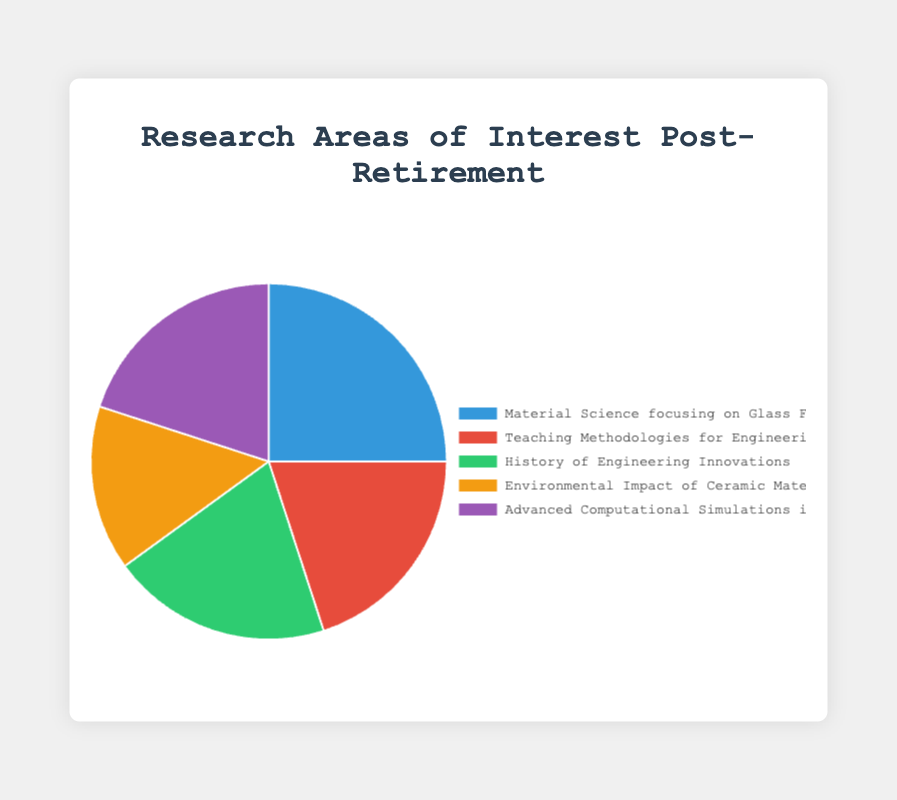What is the most prioritized research area post-retirement according to the pie chart? The highest percentage in the pie chart corresponds to the research area with the greatest priority. Here, "Material Science focusing on Glass Fracture Mechanics" has the highest percentage at 25%.
Answer: "Material Science focusing on Glass Fracture Mechanics" Which research areas have exactly the same percentage? By observing the pie chart, the areas with the same percentage are "Teaching Methodologies for Engineering Education", "History of Engineering Innovations", and "Advanced Computational Simulations in Material Engineering". Each of these areas has a 20% slice in the chart.
Answer: "Teaching Methodologies for Engineering Education", "History of Engineering Innovations", and "Advanced Computational Simulations in Material Engineering" What is the cumulative percentage of research areas related to engineering education and innovation? Adding the percentages of "Teaching Methodologies for Engineering Education" (20%) and "History of Engineering Innovations" (20%), the cumulative percentage is 20% + 20% = 40%.
Answer: 40% Does "Environmental Impact of Ceramic Materials" hold a larger or smaller percentage than "History of Engineering Innovations"? By comparing the percentages, "Environmental Impact of Ceramic Materials" has 15% while "History of Engineering Innovations" has 20%. Therefore, "Environmental Impact of Ceramic Materials" holds a smaller percentage.
Answer: Smaller What is the sum percentage of all the research areas that are directly related to material engineering? Adding the percentages of "Material Science focusing on Glass Fracture Mechanics" (25%), "Environmental Impact of Ceramic Materials" (15%), and "Advanced Computational Simulations in Material Engineering" (20%), the total is 25% + 15% + 20% = 60%.
Answer: 60% What color represents the area "Teaching Methodologies for Engineering Education" in the pie chart? The pie chart will show different colors for each slice. For "Teaching Methodologies for Engineering Education," the specified color is red.
Answer: Red Which research area holds 20% and is represented by the green slice in the chart? By checking both the percentage and corresponding color, "History of Engineering Innovations" has a 20% representation and is shown in green.
Answer: "History of Engineering Innovations" How does the percentage of "Advanced Computational Simulations in Material Engineering" compare to the percentage of "Material Science focusing on Glass Fracture Mechanics"? "Advanced Computational Simulations in Material Engineering" holds 20% while "Material Science focusing on Glass Fracture Mechanics" holds 25%. Thus, the former is 5% less than the latter.
Answer: 5% less What is the percentage difference between the largest and smallest research areas? The largest area is "Material Science focusing on Glass Fracture Mechanics" with 25%, and the smallest is "Environmental Impact of Ceramic Materials" with 15%. The difference is 25% - 15% = 10%.
Answer: 10% If someone were to focus equally on "Teaching Methodologies for Engineering Education" and "Environmental Impact of Ceramic Materials," what would their combined percentage be? Combining the percentages of these two areas results in 20% + 15% = 35%.
Answer: 35% 